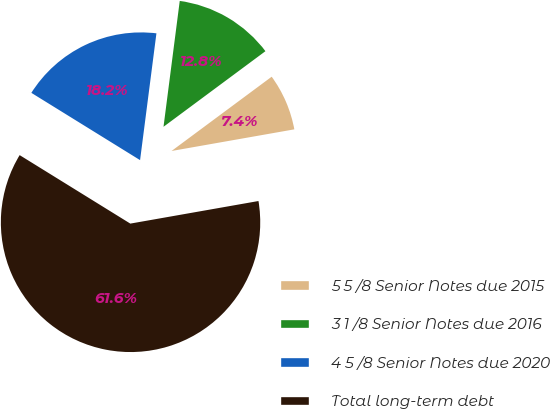<chart> <loc_0><loc_0><loc_500><loc_500><pie_chart><fcel>5 5 /8 Senior Notes due 2015<fcel>3 1 /8 Senior Notes due 2016<fcel>4 5 /8 Senior Notes due 2020<fcel>Total long-term debt<nl><fcel>7.38%<fcel>12.8%<fcel>18.22%<fcel>61.59%<nl></chart> 